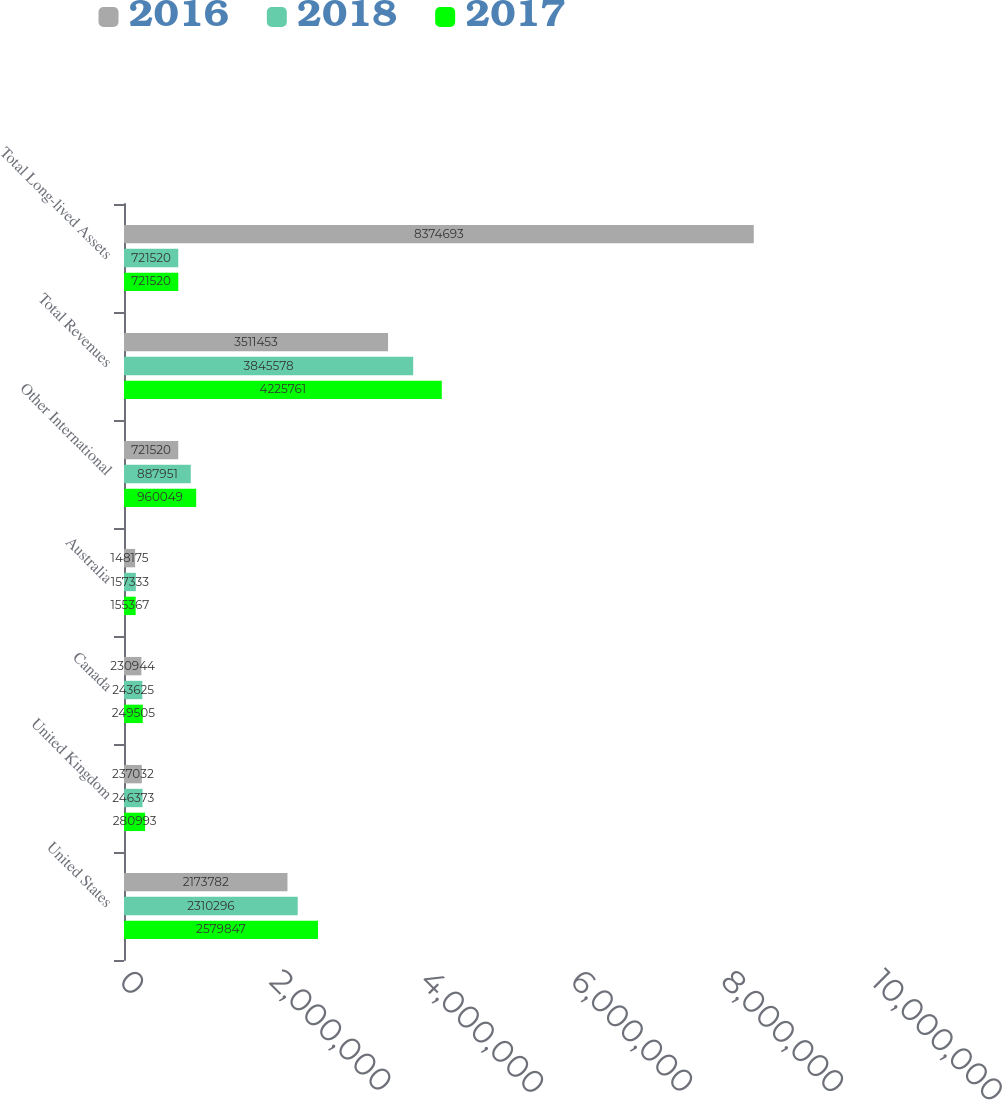<chart> <loc_0><loc_0><loc_500><loc_500><stacked_bar_chart><ecel><fcel>United States<fcel>United Kingdom<fcel>Canada<fcel>Australia<fcel>Other International<fcel>Total Revenues<fcel>Total Long-lived Assets<nl><fcel>2016<fcel>2.17378e+06<fcel>237032<fcel>230944<fcel>148175<fcel>721520<fcel>3.51145e+06<fcel>8.37469e+06<nl><fcel>2018<fcel>2.3103e+06<fcel>246373<fcel>243625<fcel>157333<fcel>887951<fcel>3.84558e+06<fcel>721520<nl><fcel>2017<fcel>2.57985e+06<fcel>280993<fcel>249505<fcel>155367<fcel>960049<fcel>4.22576e+06<fcel>721520<nl></chart> 